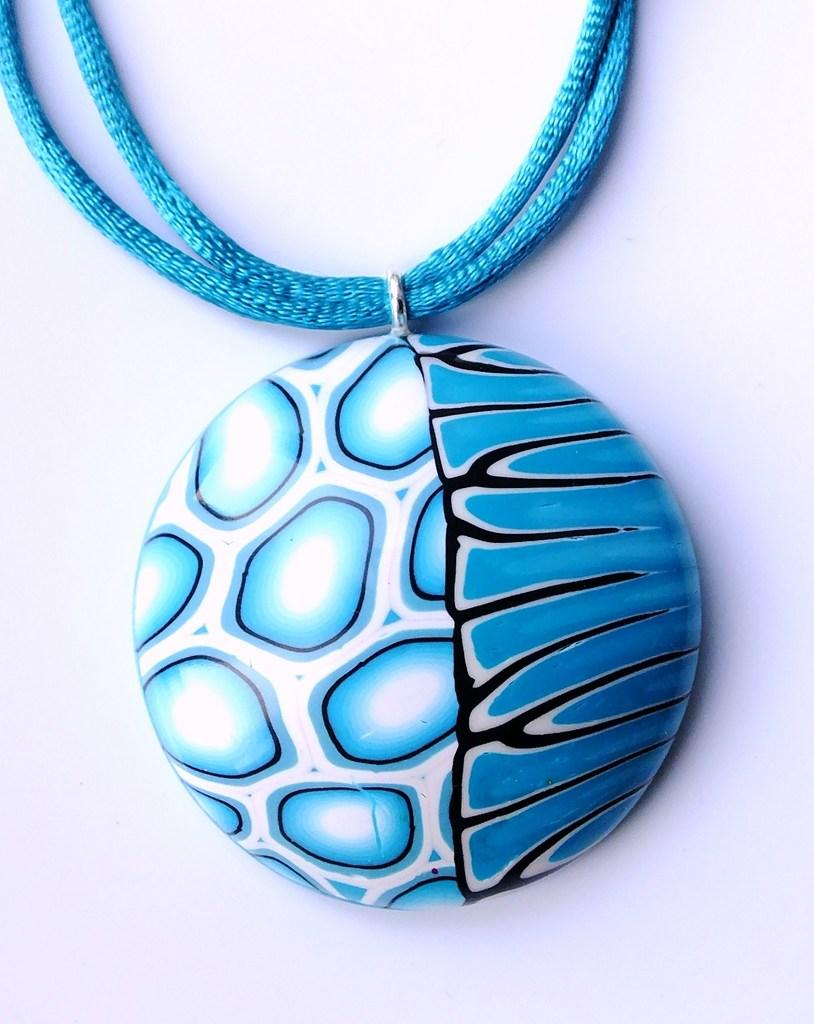What is the main object in the image? There is a chain with a locket in the image. What can be seen behind the chain and locket? There is a background in the image. Can you describe the background? The background includes a surface. What is the writer doing with the orange in the image? There is no writer or orange present in the image; it only features a chain with a locket and a background with a surface. 